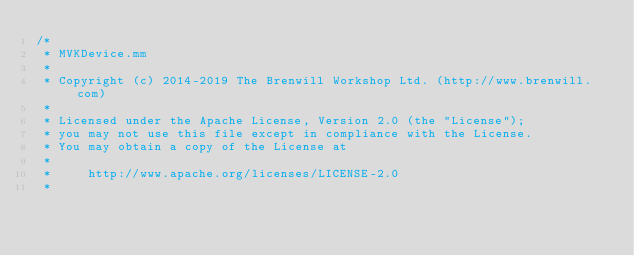Convert code to text. <code><loc_0><loc_0><loc_500><loc_500><_ObjectiveC_>/*
 * MVKDevice.mm
 *
 * Copyright (c) 2014-2019 The Brenwill Workshop Ltd. (http://www.brenwill.com)
 *
 * Licensed under the Apache License, Version 2.0 (the "License");
 * you may not use this file except in compliance with the License.
 * You may obtain a copy of the License at
 * 
 *     http://www.apache.org/licenses/LICENSE-2.0
 * </code> 